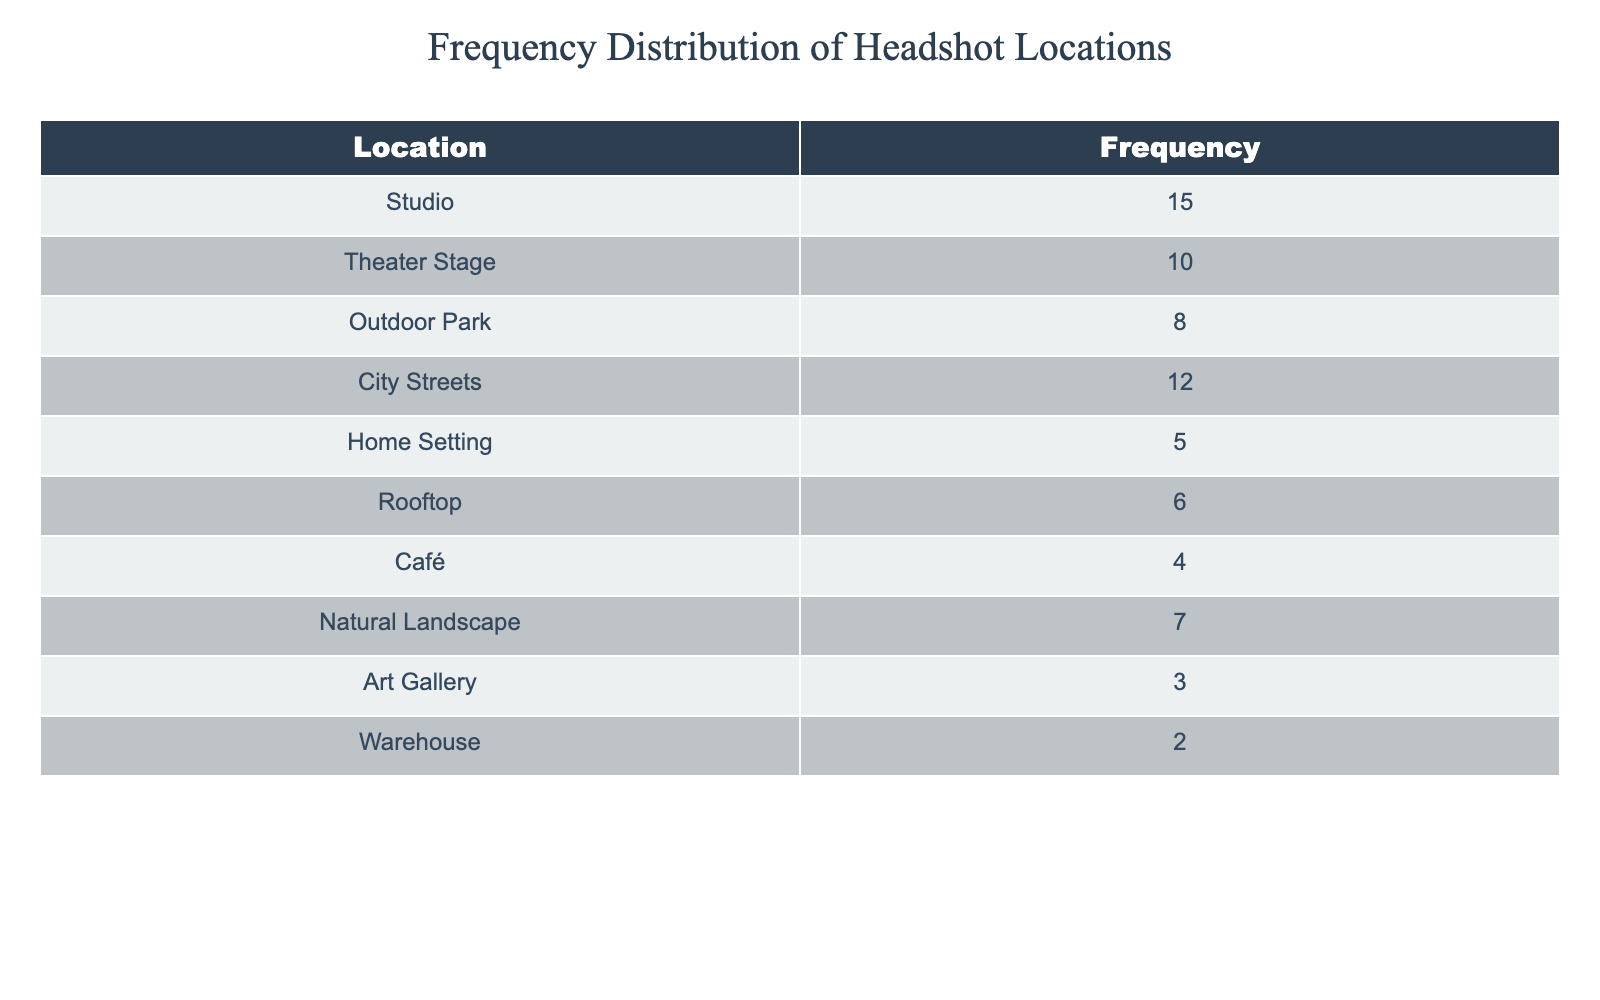What is the frequency of headshot sessions done in the Studio? The table specifies that there are 15 sessions recorded in the Studio.
Answer: 15 Which location has the highest frequency of headshot sessions? By checking the frequency values in the table, the Studio has the highest frequency with a count of 15.
Answer: Studio How many more sessions were held in City Streets compared to Art Gallery? City Streets has a frequency of 12, while the Art Gallery has a frequency of 3. The difference is calculated as 12 - 3 = 9.
Answer: 9 Is the frequency of headshot sessions in Outdoor Park greater than that in Rooftop? The frequency in Outdoor Park is 8, and for Rooftop, it is 6. Since 8 is greater than 6, the statement is true.
Answer: Yes What is the total number of headshot sessions conducted across all locations? To find the total number of sessions, we add all frequencies: 15 + 10 + 8 + 12 + 5 + 6 + 4 + 7 + 3 + 2 = 72.
Answer: 72 How many locations had a frequency greater than 6? The locations with a frequency greater than 6 are Studio (15), Theater Stage (10), City Streets (12), and Outdoor Park (8), totaling 4 locations.
Answer: 4 What is the average frequency of headshot sessions across all locations? The total frequency is 72 (from the previous calculation) and there are 10 locations. Therefore, the average is 72 / 10 = 7.2.
Answer: 7.2 Which location has the lowest frequency of headshot sessions? The Warehouse has the lowest frequency, with a count of 2 headshot sessions recorded in the table.
Answer: Warehouse How many more sessions were conducted in the Theater Stage compared to the Home Setting? The Theater Stage frequency is 10 and the Home Setting is 5. The difference is 10 - 5 = 5.
Answer: 5 